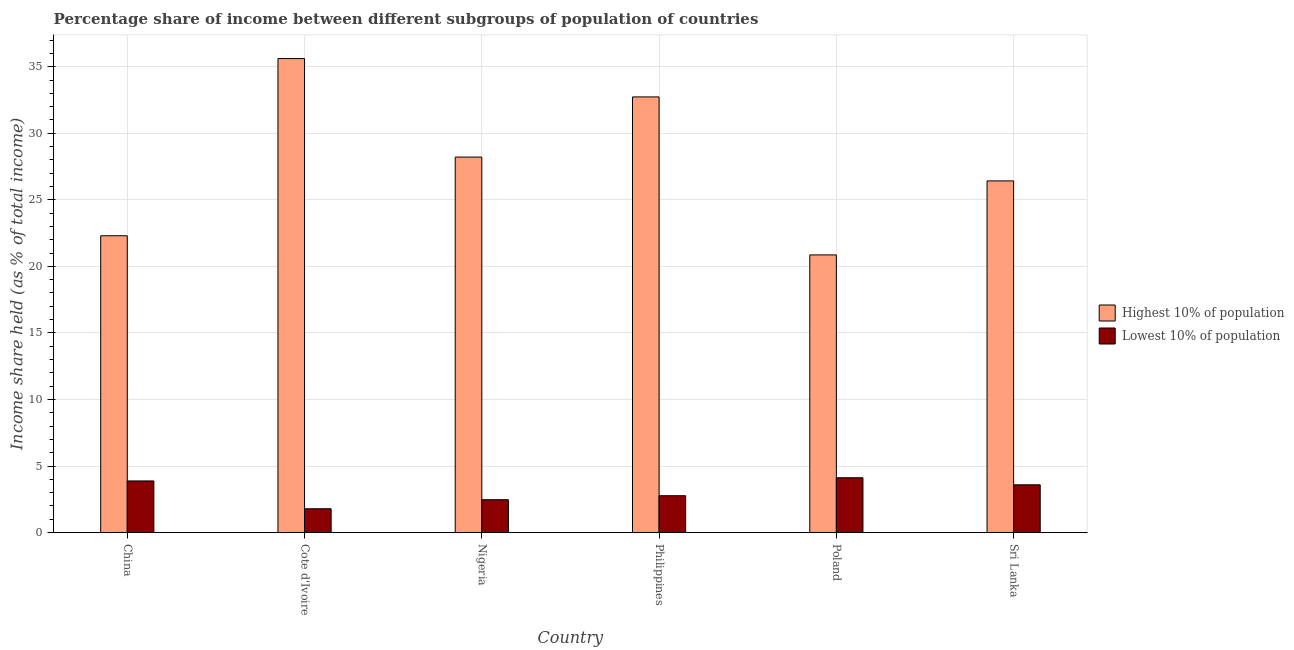How many different coloured bars are there?
Provide a succinct answer. 2. How many groups of bars are there?
Your response must be concise. 6. How many bars are there on the 2nd tick from the left?
Your answer should be very brief. 2. What is the label of the 6th group of bars from the left?
Your answer should be compact. Sri Lanka. In how many cases, is the number of bars for a given country not equal to the number of legend labels?
Your answer should be compact. 0. What is the income share held by lowest 10% of the population in Nigeria?
Provide a succinct answer. 2.47. Across all countries, what is the maximum income share held by lowest 10% of the population?
Keep it short and to the point. 4.12. Across all countries, what is the minimum income share held by lowest 10% of the population?
Your answer should be very brief. 1.79. What is the total income share held by lowest 10% of the population in the graph?
Provide a succinct answer. 18.62. What is the difference between the income share held by lowest 10% of the population in China and that in Philippines?
Your response must be concise. 1.11. What is the difference between the income share held by lowest 10% of the population in China and the income share held by highest 10% of the population in Sri Lanka?
Your response must be concise. -22.54. What is the average income share held by highest 10% of the population per country?
Make the answer very short. 27.69. What is the difference between the income share held by highest 10% of the population and income share held by lowest 10% of the population in Poland?
Provide a succinct answer. 16.74. What is the ratio of the income share held by lowest 10% of the population in Nigeria to that in Philippines?
Give a very brief answer. 0.89. Is the income share held by highest 10% of the population in China less than that in Philippines?
Offer a terse response. Yes. What is the difference between the highest and the second highest income share held by lowest 10% of the population?
Keep it short and to the point. 0.24. What is the difference between the highest and the lowest income share held by highest 10% of the population?
Your answer should be very brief. 14.75. Is the sum of the income share held by lowest 10% of the population in China and Philippines greater than the maximum income share held by highest 10% of the population across all countries?
Give a very brief answer. No. What does the 2nd bar from the left in Nigeria represents?
Offer a very short reply. Lowest 10% of population. What does the 1st bar from the right in Cote d'Ivoire represents?
Your answer should be very brief. Lowest 10% of population. How many countries are there in the graph?
Ensure brevity in your answer.  6. Are the values on the major ticks of Y-axis written in scientific E-notation?
Give a very brief answer. No. Does the graph contain any zero values?
Make the answer very short. No. Does the graph contain grids?
Offer a very short reply. Yes. How many legend labels are there?
Give a very brief answer. 2. What is the title of the graph?
Offer a terse response. Percentage share of income between different subgroups of population of countries. What is the label or title of the Y-axis?
Offer a very short reply. Income share held (as % of total income). What is the Income share held (as % of total income) of Highest 10% of population in China?
Offer a terse response. 22.3. What is the Income share held (as % of total income) in Lowest 10% of population in China?
Keep it short and to the point. 3.88. What is the Income share held (as % of total income) of Highest 10% of population in Cote d'Ivoire?
Your response must be concise. 35.61. What is the Income share held (as % of total income) in Lowest 10% of population in Cote d'Ivoire?
Keep it short and to the point. 1.79. What is the Income share held (as % of total income) of Highest 10% of population in Nigeria?
Ensure brevity in your answer.  28.21. What is the Income share held (as % of total income) in Lowest 10% of population in Nigeria?
Give a very brief answer. 2.47. What is the Income share held (as % of total income) of Highest 10% of population in Philippines?
Give a very brief answer. 32.73. What is the Income share held (as % of total income) of Lowest 10% of population in Philippines?
Offer a terse response. 2.77. What is the Income share held (as % of total income) of Highest 10% of population in Poland?
Provide a succinct answer. 20.86. What is the Income share held (as % of total income) in Lowest 10% of population in Poland?
Give a very brief answer. 4.12. What is the Income share held (as % of total income) of Highest 10% of population in Sri Lanka?
Keep it short and to the point. 26.42. What is the Income share held (as % of total income) of Lowest 10% of population in Sri Lanka?
Make the answer very short. 3.59. Across all countries, what is the maximum Income share held (as % of total income) of Highest 10% of population?
Provide a short and direct response. 35.61. Across all countries, what is the maximum Income share held (as % of total income) in Lowest 10% of population?
Offer a very short reply. 4.12. Across all countries, what is the minimum Income share held (as % of total income) of Highest 10% of population?
Ensure brevity in your answer.  20.86. Across all countries, what is the minimum Income share held (as % of total income) of Lowest 10% of population?
Your response must be concise. 1.79. What is the total Income share held (as % of total income) in Highest 10% of population in the graph?
Keep it short and to the point. 166.13. What is the total Income share held (as % of total income) in Lowest 10% of population in the graph?
Your answer should be very brief. 18.62. What is the difference between the Income share held (as % of total income) of Highest 10% of population in China and that in Cote d'Ivoire?
Offer a terse response. -13.31. What is the difference between the Income share held (as % of total income) of Lowest 10% of population in China and that in Cote d'Ivoire?
Ensure brevity in your answer.  2.09. What is the difference between the Income share held (as % of total income) in Highest 10% of population in China and that in Nigeria?
Give a very brief answer. -5.91. What is the difference between the Income share held (as % of total income) of Lowest 10% of population in China and that in Nigeria?
Keep it short and to the point. 1.41. What is the difference between the Income share held (as % of total income) of Highest 10% of population in China and that in Philippines?
Your answer should be very brief. -10.43. What is the difference between the Income share held (as % of total income) of Lowest 10% of population in China and that in Philippines?
Give a very brief answer. 1.11. What is the difference between the Income share held (as % of total income) of Highest 10% of population in China and that in Poland?
Ensure brevity in your answer.  1.44. What is the difference between the Income share held (as % of total income) of Lowest 10% of population in China and that in Poland?
Provide a short and direct response. -0.24. What is the difference between the Income share held (as % of total income) in Highest 10% of population in China and that in Sri Lanka?
Give a very brief answer. -4.12. What is the difference between the Income share held (as % of total income) of Lowest 10% of population in China and that in Sri Lanka?
Provide a short and direct response. 0.29. What is the difference between the Income share held (as % of total income) of Highest 10% of population in Cote d'Ivoire and that in Nigeria?
Your response must be concise. 7.4. What is the difference between the Income share held (as % of total income) in Lowest 10% of population in Cote d'Ivoire and that in Nigeria?
Your response must be concise. -0.68. What is the difference between the Income share held (as % of total income) in Highest 10% of population in Cote d'Ivoire and that in Philippines?
Provide a succinct answer. 2.88. What is the difference between the Income share held (as % of total income) of Lowest 10% of population in Cote d'Ivoire and that in Philippines?
Provide a short and direct response. -0.98. What is the difference between the Income share held (as % of total income) in Highest 10% of population in Cote d'Ivoire and that in Poland?
Ensure brevity in your answer.  14.75. What is the difference between the Income share held (as % of total income) in Lowest 10% of population in Cote d'Ivoire and that in Poland?
Give a very brief answer. -2.33. What is the difference between the Income share held (as % of total income) in Highest 10% of population in Cote d'Ivoire and that in Sri Lanka?
Ensure brevity in your answer.  9.19. What is the difference between the Income share held (as % of total income) of Lowest 10% of population in Cote d'Ivoire and that in Sri Lanka?
Make the answer very short. -1.8. What is the difference between the Income share held (as % of total income) in Highest 10% of population in Nigeria and that in Philippines?
Provide a short and direct response. -4.52. What is the difference between the Income share held (as % of total income) of Highest 10% of population in Nigeria and that in Poland?
Make the answer very short. 7.35. What is the difference between the Income share held (as % of total income) in Lowest 10% of population in Nigeria and that in Poland?
Keep it short and to the point. -1.65. What is the difference between the Income share held (as % of total income) in Highest 10% of population in Nigeria and that in Sri Lanka?
Provide a short and direct response. 1.79. What is the difference between the Income share held (as % of total income) of Lowest 10% of population in Nigeria and that in Sri Lanka?
Provide a succinct answer. -1.12. What is the difference between the Income share held (as % of total income) in Highest 10% of population in Philippines and that in Poland?
Keep it short and to the point. 11.87. What is the difference between the Income share held (as % of total income) of Lowest 10% of population in Philippines and that in Poland?
Provide a succinct answer. -1.35. What is the difference between the Income share held (as % of total income) of Highest 10% of population in Philippines and that in Sri Lanka?
Ensure brevity in your answer.  6.31. What is the difference between the Income share held (as % of total income) in Lowest 10% of population in Philippines and that in Sri Lanka?
Make the answer very short. -0.82. What is the difference between the Income share held (as % of total income) in Highest 10% of population in Poland and that in Sri Lanka?
Make the answer very short. -5.56. What is the difference between the Income share held (as % of total income) in Lowest 10% of population in Poland and that in Sri Lanka?
Offer a terse response. 0.53. What is the difference between the Income share held (as % of total income) of Highest 10% of population in China and the Income share held (as % of total income) of Lowest 10% of population in Cote d'Ivoire?
Offer a very short reply. 20.51. What is the difference between the Income share held (as % of total income) in Highest 10% of population in China and the Income share held (as % of total income) in Lowest 10% of population in Nigeria?
Your answer should be compact. 19.83. What is the difference between the Income share held (as % of total income) in Highest 10% of population in China and the Income share held (as % of total income) in Lowest 10% of population in Philippines?
Keep it short and to the point. 19.53. What is the difference between the Income share held (as % of total income) in Highest 10% of population in China and the Income share held (as % of total income) in Lowest 10% of population in Poland?
Provide a short and direct response. 18.18. What is the difference between the Income share held (as % of total income) of Highest 10% of population in China and the Income share held (as % of total income) of Lowest 10% of population in Sri Lanka?
Offer a terse response. 18.71. What is the difference between the Income share held (as % of total income) of Highest 10% of population in Cote d'Ivoire and the Income share held (as % of total income) of Lowest 10% of population in Nigeria?
Ensure brevity in your answer.  33.14. What is the difference between the Income share held (as % of total income) of Highest 10% of population in Cote d'Ivoire and the Income share held (as % of total income) of Lowest 10% of population in Philippines?
Offer a very short reply. 32.84. What is the difference between the Income share held (as % of total income) in Highest 10% of population in Cote d'Ivoire and the Income share held (as % of total income) in Lowest 10% of population in Poland?
Keep it short and to the point. 31.49. What is the difference between the Income share held (as % of total income) in Highest 10% of population in Cote d'Ivoire and the Income share held (as % of total income) in Lowest 10% of population in Sri Lanka?
Ensure brevity in your answer.  32.02. What is the difference between the Income share held (as % of total income) of Highest 10% of population in Nigeria and the Income share held (as % of total income) of Lowest 10% of population in Philippines?
Provide a succinct answer. 25.44. What is the difference between the Income share held (as % of total income) of Highest 10% of population in Nigeria and the Income share held (as % of total income) of Lowest 10% of population in Poland?
Make the answer very short. 24.09. What is the difference between the Income share held (as % of total income) of Highest 10% of population in Nigeria and the Income share held (as % of total income) of Lowest 10% of population in Sri Lanka?
Your answer should be compact. 24.62. What is the difference between the Income share held (as % of total income) of Highest 10% of population in Philippines and the Income share held (as % of total income) of Lowest 10% of population in Poland?
Ensure brevity in your answer.  28.61. What is the difference between the Income share held (as % of total income) in Highest 10% of population in Philippines and the Income share held (as % of total income) in Lowest 10% of population in Sri Lanka?
Provide a succinct answer. 29.14. What is the difference between the Income share held (as % of total income) of Highest 10% of population in Poland and the Income share held (as % of total income) of Lowest 10% of population in Sri Lanka?
Ensure brevity in your answer.  17.27. What is the average Income share held (as % of total income) of Highest 10% of population per country?
Offer a terse response. 27.69. What is the average Income share held (as % of total income) of Lowest 10% of population per country?
Offer a terse response. 3.1. What is the difference between the Income share held (as % of total income) of Highest 10% of population and Income share held (as % of total income) of Lowest 10% of population in China?
Your response must be concise. 18.42. What is the difference between the Income share held (as % of total income) of Highest 10% of population and Income share held (as % of total income) of Lowest 10% of population in Cote d'Ivoire?
Your answer should be very brief. 33.82. What is the difference between the Income share held (as % of total income) of Highest 10% of population and Income share held (as % of total income) of Lowest 10% of population in Nigeria?
Your answer should be compact. 25.74. What is the difference between the Income share held (as % of total income) in Highest 10% of population and Income share held (as % of total income) in Lowest 10% of population in Philippines?
Provide a succinct answer. 29.96. What is the difference between the Income share held (as % of total income) in Highest 10% of population and Income share held (as % of total income) in Lowest 10% of population in Poland?
Ensure brevity in your answer.  16.74. What is the difference between the Income share held (as % of total income) of Highest 10% of population and Income share held (as % of total income) of Lowest 10% of population in Sri Lanka?
Give a very brief answer. 22.83. What is the ratio of the Income share held (as % of total income) in Highest 10% of population in China to that in Cote d'Ivoire?
Your response must be concise. 0.63. What is the ratio of the Income share held (as % of total income) in Lowest 10% of population in China to that in Cote d'Ivoire?
Offer a terse response. 2.17. What is the ratio of the Income share held (as % of total income) of Highest 10% of population in China to that in Nigeria?
Keep it short and to the point. 0.79. What is the ratio of the Income share held (as % of total income) of Lowest 10% of population in China to that in Nigeria?
Your response must be concise. 1.57. What is the ratio of the Income share held (as % of total income) of Highest 10% of population in China to that in Philippines?
Provide a succinct answer. 0.68. What is the ratio of the Income share held (as % of total income) of Lowest 10% of population in China to that in Philippines?
Make the answer very short. 1.4. What is the ratio of the Income share held (as % of total income) of Highest 10% of population in China to that in Poland?
Your answer should be very brief. 1.07. What is the ratio of the Income share held (as % of total income) of Lowest 10% of population in China to that in Poland?
Ensure brevity in your answer.  0.94. What is the ratio of the Income share held (as % of total income) in Highest 10% of population in China to that in Sri Lanka?
Make the answer very short. 0.84. What is the ratio of the Income share held (as % of total income) of Lowest 10% of population in China to that in Sri Lanka?
Provide a short and direct response. 1.08. What is the ratio of the Income share held (as % of total income) in Highest 10% of population in Cote d'Ivoire to that in Nigeria?
Keep it short and to the point. 1.26. What is the ratio of the Income share held (as % of total income) in Lowest 10% of population in Cote d'Ivoire to that in Nigeria?
Your answer should be very brief. 0.72. What is the ratio of the Income share held (as % of total income) of Highest 10% of population in Cote d'Ivoire to that in Philippines?
Provide a succinct answer. 1.09. What is the ratio of the Income share held (as % of total income) of Lowest 10% of population in Cote d'Ivoire to that in Philippines?
Offer a terse response. 0.65. What is the ratio of the Income share held (as % of total income) of Highest 10% of population in Cote d'Ivoire to that in Poland?
Keep it short and to the point. 1.71. What is the ratio of the Income share held (as % of total income) in Lowest 10% of population in Cote d'Ivoire to that in Poland?
Your answer should be compact. 0.43. What is the ratio of the Income share held (as % of total income) in Highest 10% of population in Cote d'Ivoire to that in Sri Lanka?
Your response must be concise. 1.35. What is the ratio of the Income share held (as % of total income) of Lowest 10% of population in Cote d'Ivoire to that in Sri Lanka?
Provide a succinct answer. 0.5. What is the ratio of the Income share held (as % of total income) of Highest 10% of population in Nigeria to that in Philippines?
Provide a short and direct response. 0.86. What is the ratio of the Income share held (as % of total income) in Lowest 10% of population in Nigeria to that in Philippines?
Make the answer very short. 0.89. What is the ratio of the Income share held (as % of total income) of Highest 10% of population in Nigeria to that in Poland?
Keep it short and to the point. 1.35. What is the ratio of the Income share held (as % of total income) in Lowest 10% of population in Nigeria to that in Poland?
Keep it short and to the point. 0.6. What is the ratio of the Income share held (as % of total income) of Highest 10% of population in Nigeria to that in Sri Lanka?
Your answer should be very brief. 1.07. What is the ratio of the Income share held (as % of total income) in Lowest 10% of population in Nigeria to that in Sri Lanka?
Provide a succinct answer. 0.69. What is the ratio of the Income share held (as % of total income) in Highest 10% of population in Philippines to that in Poland?
Make the answer very short. 1.57. What is the ratio of the Income share held (as % of total income) of Lowest 10% of population in Philippines to that in Poland?
Offer a very short reply. 0.67. What is the ratio of the Income share held (as % of total income) in Highest 10% of population in Philippines to that in Sri Lanka?
Give a very brief answer. 1.24. What is the ratio of the Income share held (as % of total income) in Lowest 10% of population in Philippines to that in Sri Lanka?
Provide a succinct answer. 0.77. What is the ratio of the Income share held (as % of total income) in Highest 10% of population in Poland to that in Sri Lanka?
Ensure brevity in your answer.  0.79. What is the ratio of the Income share held (as % of total income) in Lowest 10% of population in Poland to that in Sri Lanka?
Provide a succinct answer. 1.15. What is the difference between the highest and the second highest Income share held (as % of total income) in Highest 10% of population?
Offer a terse response. 2.88. What is the difference between the highest and the second highest Income share held (as % of total income) of Lowest 10% of population?
Make the answer very short. 0.24. What is the difference between the highest and the lowest Income share held (as % of total income) of Highest 10% of population?
Your answer should be compact. 14.75. What is the difference between the highest and the lowest Income share held (as % of total income) in Lowest 10% of population?
Give a very brief answer. 2.33. 